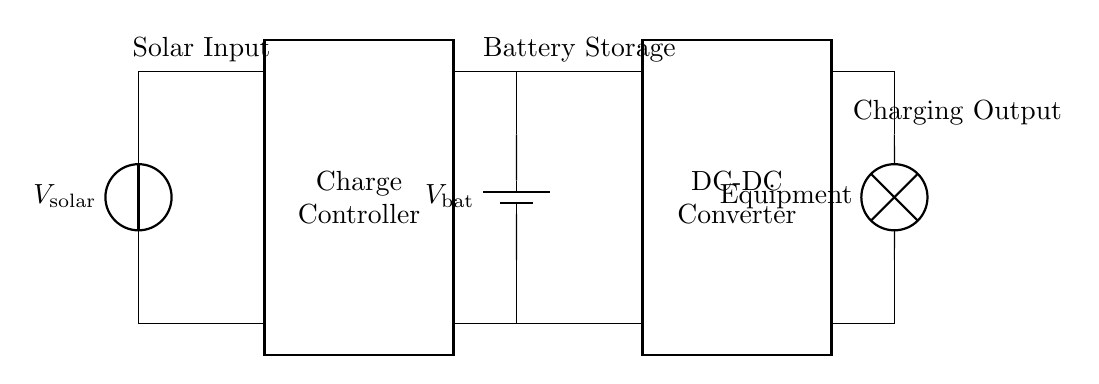What is the main power source for the charging station? The main power source is the solar panel, which converts solar energy into electrical energy.
Answer: Solar panel What is the function of the charge controller in this circuit? The charge controller regulates the voltage and current coming from the solar panel to ensure the battery is charged safely and efficiently.
Answer: Regulates charging What type of battery is used in this circuit? The battery is a direct current (DC) battery, indicated by the 'battery1' symbol in the circuit.
Answer: DC battery How many components are there in the main power path? Counting from the solar panel to the equipment, there are four main components: the solar panel, charge controller, battery, and DC-DC converter.
Answer: Four What voltage does the equipment need to operate? The equipment operates at the output voltage after the DC-DC converter; this information is not explicitly labeled but can be inferred as suitable for operating voltage levels.
Answer: Not labeled Why is a DC-DC converter necessary in this circuit? The DC-DC converter is used to convert the battery's voltage to a suitable level for the equipment, ensuring compatibility and efficiency.
Answer: To adjust voltage What do the connections between components signify? The connections indicate the flow of electricity from the solar panel to the charge controller, then to the battery, and finally to the output for the equipment, illustrating the path of power management.
Answer: Power flow 